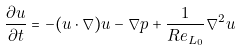Convert formula to latex. <formula><loc_0><loc_0><loc_500><loc_500>\frac { \partial u } { \partial t } = - ( u \cdot \nabla ) u - \nabla p + \frac { 1 } { R e _ { L _ { 0 } } } \nabla ^ { 2 } u</formula> 